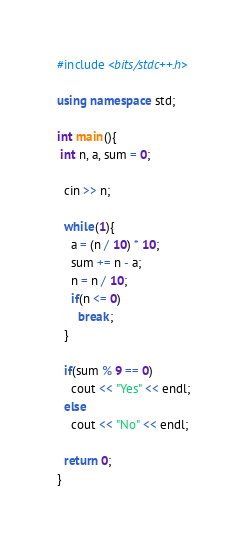Convert code to text. <code><loc_0><loc_0><loc_500><loc_500><_C++_>#include <bits/stdc++.h>

using namespace std;

int main(){
 int n, a, sum = 0;
  
  cin >> n;
  
  while(1){
    a = (n / 10) * 10;
    sum += n - a;
    n = n / 10;
    if(n <= 0)
      break;
  }
  
  if(sum % 9 == 0)
    cout << "Yes" << endl;
  else
    cout << "No" << endl;
  
  return 0;
}</code> 